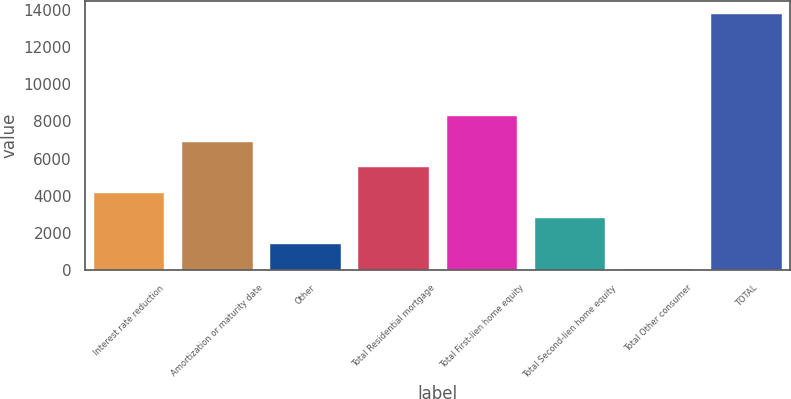Convert chart. <chart><loc_0><loc_0><loc_500><loc_500><bar_chart><fcel>Interest rate reduction<fcel>Amortization or maturity date<fcel>Other<fcel>Total Residential mortgage<fcel>Total First-lien home equity<fcel>Total Second-lien home equity<fcel>Total Other consumer<fcel>TOTAL<nl><fcel>4168.4<fcel>6912<fcel>1424.8<fcel>5540.2<fcel>8283.8<fcel>2796.6<fcel>53<fcel>13771<nl></chart> 